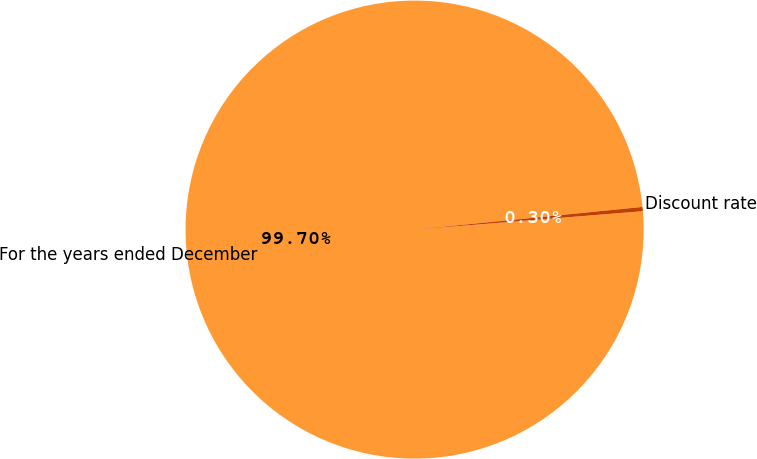Convert chart to OTSL. <chart><loc_0><loc_0><loc_500><loc_500><pie_chart><fcel>For the years ended December<fcel>Discount rate<nl><fcel>99.7%<fcel>0.3%<nl></chart> 